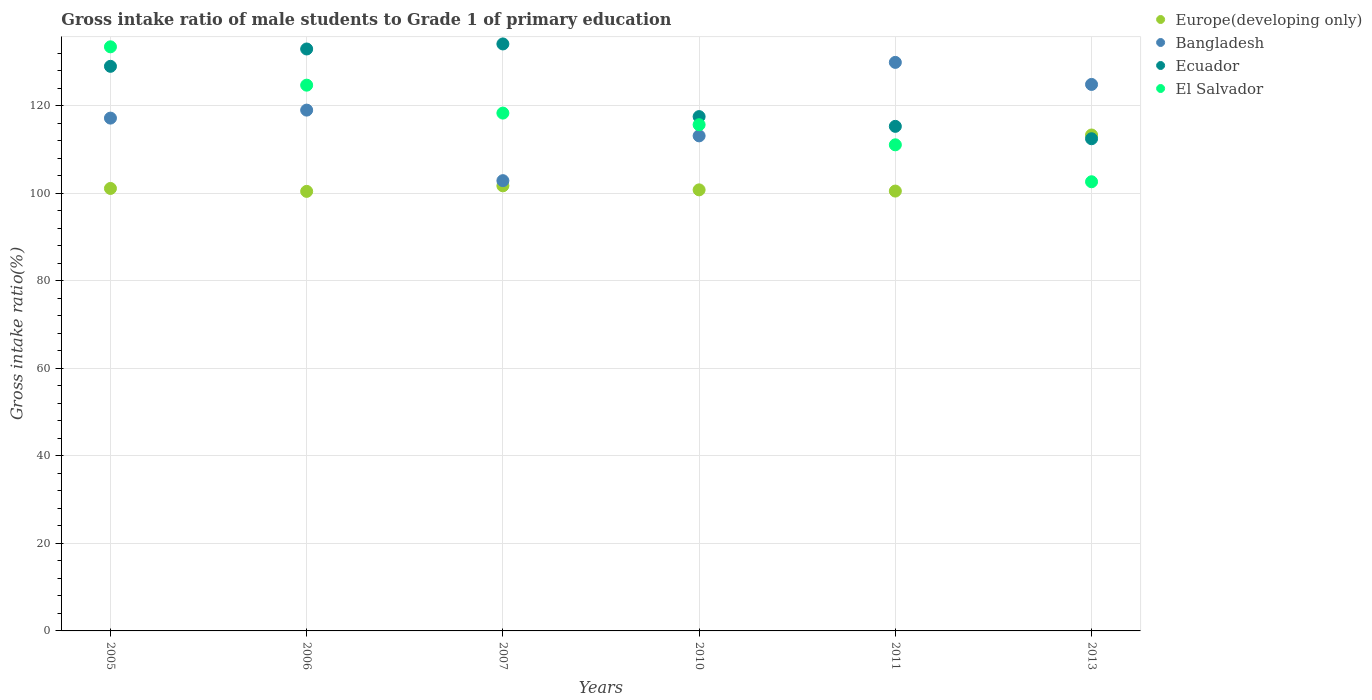What is the gross intake ratio in Europe(developing only) in 2007?
Provide a short and direct response. 101.71. Across all years, what is the maximum gross intake ratio in Ecuador?
Provide a short and direct response. 134.14. Across all years, what is the minimum gross intake ratio in Ecuador?
Offer a terse response. 112.47. What is the total gross intake ratio in Europe(developing only) in the graph?
Make the answer very short. 617.91. What is the difference between the gross intake ratio in Europe(developing only) in 2006 and that in 2010?
Make the answer very short. -0.35. What is the difference between the gross intake ratio in Bangladesh in 2013 and the gross intake ratio in Europe(developing only) in 2007?
Make the answer very short. 23.17. What is the average gross intake ratio in Bangladesh per year?
Provide a short and direct response. 117.84. In the year 2007, what is the difference between the gross intake ratio in Europe(developing only) and gross intake ratio in El Salvador?
Provide a short and direct response. -16.62. What is the ratio of the gross intake ratio in Europe(developing only) in 2005 to that in 2006?
Give a very brief answer. 1.01. Is the gross intake ratio in El Salvador in 2006 less than that in 2007?
Provide a succinct answer. No. Is the difference between the gross intake ratio in Europe(developing only) in 2010 and 2013 greater than the difference between the gross intake ratio in El Salvador in 2010 and 2013?
Keep it short and to the point. No. What is the difference between the highest and the second highest gross intake ratio in Bangladesh?
Your response must be concise. 5.04. What is the difference between the highest and the lowest gross intake ratio in Bangladesh?
Offer a terse response. 27.03. In how many years, is the gross intake ratio in Bangladesh greater than the average gross intake ratio in Bangladesh taken over all years?
Give a very brief answer. 3. Is it the case that in every year, the sum of the gross intake ratio in Bangladesh and gross intake ratio in Europe(developing only)  is greater than the gross intake ratio in El Salvador?
Offer a terse response. Yes. Does the gross intake ratio in Bangladesh monotonically increase over the years?
Offer a terse response. No. How many years are there in the graph?
Your answer should be very brief. 6. What is the difference between two consecutive major ticks on the Y-axis?
Offer a terse response. 20. How many legend labels are there?
Give a very brief answer. 4. How are the legend labels stacked?
Your answer should be compact. Vertical. What is the title of the graph?
Provide a short and direct response. Gross intake ratio of male students to Grade 1 of primary education. What is the label or title of the X-axis?
Make the answer very short. Years. What is the label or title of the Y-axis?
Your response must be concise. Gross intake ratio(%). What is the Gross intake ratio(%) of Europe(developing only) in 2005?
Give a very brief answer. 101.11. What is the Gross intake ratio(%) in Bangladesh in 2005?
Provide a short and direct response. 117.19. What is the Gross intake ratio(%) in Ecuador in 2005?
Your answer should be compact. 129.02. What is the Gross intake ratio(%) of El Salvador in 2005?
Your answer should be compact. 133.48. What is the Gross intake ratio(%) in Europe(developing only) in 2006?
Keep it short and to the point. 100.44. What is the Gross intake ratio(%) of Bangladesh in 2006?
Ensure brevity in your answer.  119.02. What is the Gross intake ratio(%) of Ecuador in 2006?
Provide a short and direct response. 132.98. What is the Gross intake ratio(%) in El Salvador in 2006?
Ensure brevity in your answer.  124.72. What is the Gross intake ratio(%) in Europe(developing only) in 2007?
Your answer should be compact. 101.71. What is the Gross intake ratio(%) in Bangladesh in 2007?
Ensure brevity in your answer.  102.89. What is the Gross intake ratio(%) in Ecuador in 2007?
Offer a very short reply. 134.14. What is the Gross intake ratio(%) of El Salvador in 2007?
Offer a very short reply. 118.33. What is the Gross intake ratio(%) of Europe(developing only) in 2010?
Provide a succinct answer. 100.79. What is the Gross intake ratio(%) of Bangladesh in 2010?
Offer a terse response. 113.13. What is the Gross intake ratio(%) in Ecuador in 2010?
Make the answer very short. 117.53. What is the Gross intake ratio(%) in El Salvador in 2010?
Provide a succinct answer. 115.68. What is the Gross intake ratio(%) in Europe(developing only) in 2011?
Provide a succinct answer. 100.51. What is the Gross intake ratio(%) of Bangladesh in 2011?
Ensure brevity in your answer.  129.92. What is the Gross intake ratio(%) of Ecuador in 2011?
Give a very brief answer. 115.3. What is the Gross intake ratio(%) of El Salvador in 2011?
Give a very brief answer. 111.08. What is the Gross intake ratio(%) in Europe(developing only) in 2013?
Your response must be concise. 113.33. What is the Gross intake ratio(%) of Bangladesh in 2013?
Offer a very short reply. 124.88. What is the Gross intake ratio(%) of Ecuador in 2013?
Offer a terse response. 112.47. What is the Gross intake ratio(%) in El Salvador in 2013?
Provide a succinct answer. 102.64. Across all years, what is the maximum Gross intake ratio(%) in Europe(developing only)?
Keep it short and to the point. 113.33. Across all years, what is the maximum Gross intake ratio(%) in Bangladesh?
Provide a succinct answer. 129.92. Across all years, what is the maximum Gross intake ratio(%) of Ecuador?
Make the answer very short. 134.14. Across all years, what is the maximum Gross intake ratio(%) in El Salvador?
Make the answer very short. 133.48. Across all years, what is the minimum Gross intake ratio(%) in Europe(developing only)?
Your answer should be very brief. 100.44. Across all years, what is the minimum Gross intake ratio(%) of Bangladesh?
Ensure brevity in your answer.  102.89. Across all years, what is the minimum Gross intake ratio(%) of Ecuador?
Provide a succinct answer. 112.47. Across all years, what is the minimum Gross intake ratio(%) in El Salvador?
Offer a very short reply. 102.64. What is the total Gross intake ratio(%) in Europe(developing only) in the graph?
Offer a terse response. 617.91. What is the total Gross intake ratio(%) of Bangladesh in the graph?
Give a very brief answer. 707.03. What is the total Gross intake ratio(%) in Ecuador in the graph?
Offer a very short reply. 741.45. What is the total Gross intake ratio(%) in El Salvador in the graph?
Offer a terse response. 705.93. What is the difference between the Gross intake ratio(%) of Europe(developing only) in 2005 and that in 2006?
Offer a terse response. 0.67. What is the difference between the Gross intake ratio(%) in Bangladesh in 2005 and that in 2006?
Make the answer very short. -1.83. What is the difference between the Gross intake ratio(%) of Ecuador in 2005 and that in 2006?
Provide a succinct answer. -3.96. What is the difference between the Gross intake ratio(%) of El Salvador in 2005 and that in 2006?
Your answer should be very brief. 8.76. What is the difference between the Gross intake ratio(%) in Europe(developing only) in 2005 and that in 2007?
Offer a terse response. -0.6. What is the difference between the Gross intake ratio(%) in Bangladesh in 2005 and that in 2007?
Offer a terse response. 14.29. What is the difference between the Gross intake ratio(%) of Ecuador in 2005 and that in 2007?
Keep it short and to the point. -5.11. What is the difference between the Gross intake ratio(%) in El Salvador in 2005 and that in 2007?
Keep it short and to the point. 15.15. What is the difference between the Gross intake ratio(%) in Europe(developing only) in 2005 and that in 2010?
Your answer should be compact. 0.32. What is the difference between the Gross intake ratio(%) in Bangladesh in 2005 and that in 2010?
Offer a very short reply. 4.06. What is the difference between the Gross intake ratio(%) in Ecuador in 2005 and that in 2010?
Provide a short and direct response. 11.49. What is the difference between the Gross intake ratio(%) of El Salvador in 2005 and that in 2010?
Provide a short and direct response. 17.8. What is the difference between the Gross intake ratio(%) in Europe(developing only) in 2005 and that in 2011?
Provide a succinct answer. 0.6. What is the difference between the Gross intake ratio(%) in Bangladesh in 2005 and that in 2011?
Provide a succinct answer. -12.73. What is the difference between the Gross intake ratio(%) in Ecuador in 2005 and that in 2011?
Offer a terse response. 13.72. What is the difference between the Gross intake ratio(%) in El Salvador in 2005 and that in 2011?
Ensure brevity in your answer.  22.39. What is the difference between the Gross intake ratio(%) of Europe(developing only) in 2005 and that in 2013?
Keep it short and to the point. -12.21. What is the difference between the Gross intake ratio(%) of Bangladesh in 2005 and that in 2013?
Give a very brief answer. -7.7. What is the difference between the Gross intake ratio(%) of Ecuador in 2005 and that in 2013?
Offer a terse response. 16.55. What is the difference between the Gross intake ratio(%) of El Salvador in 2005 and that in 2013?
Your response must be concise. 30.84. What is the difference between the Gross intake ratio(%) of Europe(developing only) in 2006 and that in 2007?
Ensure brevity in your answer.  -1.27. What is the difference between the Gross intake ratio(%) in Bangladesh in 2006 and that in 2007?
Provide a short and direct response. 16.12. What is the difference between the Gross intake ratio(%) in Ecuador in 2006 and that in 2007?
Offer a very short reply. -1.15. What is the difference between the Gross intake ratio(%) in El Salvador in 2006 and that in 2007?
Your response must be concise. 6.38. What is the difference between the Gross intake ratio(%) of Europe(developing only) in 2006 and that in 2010?
Make the answer very short. -0.35. What is the difference between the Gross intake ratio(%) in Bangladesh in 2006 and that in 2010?
Your response must be concise. 5.89. What is the difference between the Gross intake ratio(%) of Ecuador in 2006 and that in 2010?
Give a very brief answer. 15.45. What is the difference between the Gross intake ratio(%) of El Salvador in 2006 and that in 2010?
Make the answer very short. 9.03. What is the difference between the Gross intake ratio(%) in Europe(developing only) in 2006 and that in 2011?
Your answer should be very brief. -0.07. What is the difference between the Gross intake ratio(%) of Bangladesh in 2006 and that in 2011?
Offer a very short reply. -10.91. What is the difference between the Gross intake ratio(%) in Ecuador in 2006 and that in 2011?
Provide a succinct answer. 17.68. What is the difference between the Gross intake ratio(%) of El Salvador in 2006 and that in 2011?
Your answer should be very brief. 13.63. What is the difference between the Gross intake ratio(%) of Europe(developing only) in 2006 and that in 2013?
Make the answer very short. -12.88. What is the difference between the Gross intake ratio(%) in Bangladesh in 2006 and that in 2013?
Provide a succinct answer. -5.87. What is the difference between the Gross intake ratio(%) in Ecuador in 2006 and that in 2013?
Give a very brief answer. 20.51. What is the difference between the Gross intake ratio(%) of El Salvador in 2006 and that in 2013?
Ensure brevity in your answer.  22.07. What is the difference between the Gross intake ratio(%) in Europe(developing only) in 2007 and that in 2010?
Provide a succinct answer. 0.92. What is the difference between the Gross intake ratio(%) in Bangladesh in 2007 and that in 2010?
Make the answer very short. -10.24. What is the difference between the Gross intake ratio(%) of Ecuador in 2007 and that in 2010?
Offer a terse response. 16.6. What is the difference between the Gross intake ratio(%) in El Salvador in 2007 and that in 2010?
Offer a very short reply. 2.65. What is the difference between the Gross intake ratio(%) of Europe(developing only) in 2007 and that in 2011?
Give a very brief answer. 1.2. What is the difference between the Gross intake ratio(%) of Bangladesh in 2007 and that in 2011?
Keep it short and to the point. -27.03. What is the difference between the Gross intake ratio(%) in Ecuador in 2007 and that in 2011?
Offer a very short reply. 18.83. What is the difference between the Gross intake ratio(%) in El Salvador in 2007 and that in 2011?
Provide a short and direct response. 7.25. What is the difference between the Gross intake ratio(%) of Europe(developing only) in 2007 and that in 2013?
Ensure brevity in your answer.  -11.61. What is the difference between the Gross intake ratio(%) in Bangladesh in 2007 and that in 2013?
Ensure brevity in your answer.  -21.99. What is the difference between the Gross intake ratio(%) in Ecuador in 2007 and that in 2013?
Keep it short and to the point. 21.66. What is the difference between the Gross intake ratio(%) of El Salvador in 2007 and that in 2013?
Your answer should be very brief. 15.69. What is the difference between the Gross intake ratio(%) of Europe(developing only) in 2010 and that in 2011?
Your answer should be compact. 0.28. What is the difference between the Gross intake ratio(%) in Bangladesh in 2010 and that in 2011?
Give a very brief answer. -16.79. What is the difference between the Gross intake ratio(%) of Ecuador in 2010 and that in 2011?
Give a very brief answer. 2.23. What is the difference between the Gross intake ratio(%) in El Salvador in 2010 and that in 2011?
Make the answer very short. 4.6. What is the difference between the Gross intake ratio(%) of Europe(developing only) in 2010 and that in 2013?
Give a very brief answer. -12.54. What is the difference between the Gross intake ratio(%) of Bangladesh in 2010 and that in 2013?
Provide a succinct answer. -11.76. What is the difference between the Gross intake ratio(%) in Ecuador in 2010 and that in 2013?
Your answer should be very brief. 5.06. What is the difference between the Gross intake ratio(%) in El Salvador in 2010 and that in 2013?
Offer a terse response. 13.04. What is the difference between the Gross intake ratio(%) in Europe(developing only) in 2011 and that in 2013?
Your response must be concise. -12.81. What is the difference between the Gross intake ratio(%) in Bangladesh in 2011 and that in 2013?
Your answer should be compact. 5.04. What is the difference between the Gross intake ratio(%) of Ecuador in 2011 and that in 2013?
Keep it short and to the point. 2.83. What is the difference between the Gross intake ratio(%) of El Salvador in 2011 and that in 2013?
Provide a succinct answer. 8.44. What is the difference between the Gross intake ratio(%) of Europe(developing only) in 2005 and the Gross intake ratio(%) of Bangladesh in 2006?
Give a very brief answer. -17.9. What is the difference between the Gross intake ratio(%) of Europe(developing only) in 2005 and the Gross intake ratio(%) of Ecuador in 2006?
Keep it short and to the point. -31.87. What is the difference between the Gross intake ratio(%) in Europe(developing only) in 2005 and the Gross intake ratio(%) in El Salvador in 2006?
Give a very brief answer. -23.6. What is the difference between the Gross intake ratio(%) in Bangladesh in 2005 and the Gross intake ratio(%) in Ecuador in 2006?
Your response must be concise. -15.8. What is the difference between the Gross intake ratio(%) of Bangladesh in 2005 and the Gross intake ratio(%) of El Salvador in 2006?
Offer a terse response. -7.53. What is the difference between the Gross intake ratio(%) in Ecuador in 2005 and the Gross intake ratio(%) in El Salvador in 2006?
Your answer should be very brief. 4.31. What is the difference between the Gross intake ratio(%) of Europe(developing only) in 2005 and the Gross intake ratio(%) of Bangladesh in 2007?
Your answer should be very brief. -1.78. What is the difference between the Gross intake ratio(%) in Europe(developing only) in 2005 and the Gross intake ratio(%) in Ecuador in 2007?
Your response must be concise. -33.02. What is the difference between the Gross intake ratio(%) of Europe(developing only) in 2005 and the Gross intake ratio(%) of El Salvador in 2007?
Your answer should be compact. -17.22. What is the difference between the Gross intake ratio(%) of Bangladesh in 2005 and the Gross intake ratio(%) of Ecuador in 2007?
Offer a terse response. -16.95. What is the difference between the Gross intake ratio(%) in Bangladesh in 2005 and the Gross intake ratio(%) in El Salvador in 2007?
Provide a short and direct response. -1.15. What is the difference between the Gross intake ratio(%) of Ecuador in 2005 and the Gross intake ratio(%) of El Salvador in 2007?
Your answer should be very brief. 10.69. What is the difference between the Gross intake ratio(%) in Europe(developing only) in 2005 and the Gross intake ratio(%) in Bangladesh in 2010?
Your answer should be very brief. -12.02. What is the difference between the Gross intake ratio(%) in Europe(developing only) in 2005 and the Gross intake ratio(%) in Ecuador in 2010?
Provide a short and direct response. -16.42. What is the difference between the Gross intake ratio(%) in Europe(developing only) in 2005 and the Gross intake ratio(%) in El Salvador in 2010?
Provide a succinct answer. -14.57. What is the difference between the Gross intake ratio(%) of Bangladesh in 2005 and the Gross intake ratio(%) of Ecuador in 2010?
Your response must be concise. -0.34. What is the difference between the Gross intake ratio(%) of Bangladesh in 2005 and the Gross intake ratio(%) of El Salvador in 2010?
Offer a very short reply. 1.51. What is the difference between the Gross intake ratio(%) in Ecuador in 2005 and the Gross intake ratio(%) in El Salvador in 2010?
Provide a short and direct response. 13.34. What is the difference between the Gross intake ratio(%) in Europe(developing only) in 2005 and the Gross intake ratio(%) in Bangladesh in 2011?
Your answer should be very brief. -28.81. What is the difference between the Gross intake ratio(%) in Europe(developing only) in 2005 and the Gross intake ratio(%) in Ecuador in 2011?
Offer a terse response. -14.19. What is the difference between the Gross intake ratio(%) of Europe(developing only) in 2005 and the Gross intake ratio(%) of El Salvador in 2011?
Provide a short and direct response. -9.97. What is the difference between the Gross intake ratio(%) of Bangladesh in 2005 and the Gross intake ratio(%) of Ecuador in 2011?
Offer a very short reply. 1.88. What is the difference between the Gross intake ratio(%) of Bangladesh in 2005 and the Gross intake ratio(%) of El Salvador in 2011?
Make the answer very short. 6.1. What is the difference between the Gross intake ratio(%) of Ecuador in 2005 and the Gross intake ratio(%) of El Salvador in 2011?
Offer a terse response. 17.94. What is the difference between the Gross intake ratio(%) in Europe(developing only) in 2005 and the Gross intake ratio(%) in Bangladesh in 2013?
Provide a succinct answer. -23.77. What is the difference between the Gross intake ratio(%) in Europe(developing only) in 2005 and the Gross intake ratio(%) in Ecuador in 2013?
Make the answer very short. -11.36. What is the difference between the Gross intake ratio(%) in Europe(developing only) in 2005 and the Gross intake ratio(%) in El Salvador in 2013?
Provide a short and direct response. -1.53. What is the difference between the Gross intake ratio(%) in Bangladesh in 2005 and the Gross intake ratio(%) in Ecuador in 2013?
Give a very brief answer. 4.71. What is the difference between the Gross intake ratio(%) in Bangladesh in 2005 and the Gross intake ratio(%) in El Salvador in 2013?
Ensure brevity in your answer.  14.54. What is the difference between the Gross intake ratio(%) of Ecuador in 2005 and the Gross intake ratio(%) of El Salvador in 2013?
Ensure brevity in your answer.  26.38. What is the difference between the Gross intake ratio(%) in Europe(developing only) in 2006 and the Gross intake ratio(%) in Bangladesh in 2007?
Provide a succinct answer. -2.45. What is the difference between the Gross intake ratio(%) of Europe(developing only) in 2006 and the Gross intake ratio(%) of Ecuador in 2007?
Offer a terse response. -33.69. What is the difference between the Gross intake ratio(%) of Europe(developing only) in 2006 and the Gross intake ratio(%) of El Salvador in 2007?
Keep it short and to the point. -17.89. What is the difference between the Gross intake ratio(%) in Bangladesh in 2006 and the Gross intake ratio(%) in Ecuador in 2007?
Give a very brief answer. -15.12. What is the difference between the Gross intake ratio(%) in Bangladesh in 2006 and the Gross intake ratio(%) in El Salvador in 2007?
Your answer should be compact. 0.68. What is the difference between the Gross intake ratio(%) in Ecuador in 2006 and the Gross intake ratio(%) in El Salvador in 2007?
Give a very brief answer. 14.65. What is the difference between the Gross intake ratio(%) in Europe(developing only) in 2006 and the Gross intake ratio(%) in Bangladesh in 2010?
Offer a very short reply. -12.68. What is the difference between the Gross intake ratio(%) in Europe(developing only) in 2006 and the Gross intake ratio(%) in Ecuador in 2010?
Give a very brief answer. -17.09. What is the difference between the Gross intake ratio(%) in Europe(developing only) in 2006 and the Gross intake ratio(%) in El Salvador in 2010?
Your response must be concise. -15.24. What is the difference between the Gross intake ratio(%) of Bangladesh in 2006 and the Gross intake ratio(%) of Ecuador in 2010?
Give a very brief answer. 1.48. What is the difference between the Gross intake ratio(%) of Bangladesh in 2006 and the Gross intake ratio(%) of El Salvador in 2010?
Your answer should be very brief. 3.33. What is the difference between the Gross intake ratio(%) in Ecuador in 2006 and the Gross intake ratio(%) in El Salvador in 2010?
Make the answer very short. 17.3. What is the difference between the Gross intake ratio(%) in Europe(developing only) in 2006 and the Gross intake ratio(%) in Bangladesh in 2011?
Your answer should be very brief. -29.48. What is the difference between the Gross intake ratio(%) in Europe(developing only) in 2006 and the Gross intake ratio(%) in Ecuador in 2011?
Your answer should be very brief. -14.86. What is the difference between the Gross intake ratio(%) of Europe(developing only) in 2006 and the Gross intake ratio(%) of El Salvador in 2011?
Offer a terse response. -10.64. What is the difference between the Gross intake ratio(%) of Bangladesh in 2006 and the Gross intake ratio(%) of Ecuador in 2011?
Offer a terse response. 3.71. What is the difference between the Gross intake ratio(%) in Bangladesh in 2006 and the Gross intake ratio(%) in El Salvador in 2011?
Offer a very short reply. 7.93. What is the difference between the Gross intake ratio(%) of Ecuador in 2006 and the Gross intake ratio(%) of El Salvador in 2011?
Provide a succinct answer. 21.9. What is the difference between the Gross intake ratio(%) of Europe(developing only) in 2006 and the Gross intake ratio(%) of Bangladesh in 2013?
Your response must be concise. -24.44. What is the difference between the Gross intake ratio(%) in Europe(developing only) in 2006 and the Gross intake ratio(%) in Ecuador in 2013?
Offer a terse response. -12.03. What is the difference between the Gross intake ratio(%) in Europe(developing only) in 2006 and the Gross intake ratio(%) in El Salvador in 2013?
Give a very brief answer. -2.2. What is the difference between the Gross intake ratio(%) in Bangladesh in 2006 and the Gross intake ratio(%) in Ecuador in 2013?
Your response must be concise. 6.54. What is the difference between the Gross intake ratio(%) in Bangladesh in 2006 and the Gross intake ratio(%) in El Salvador in 2013?
Make the answer very short. 16.37. What is the difference between the Gross intake ratio(%) of Ecuador in 2006 and the Gross intake ratio(%) of El Salvador in 2013?
Make the answer very short. 30.34. What is the difference between the Gross intake ratio(%) in Europe(developing only) in 2007 and the Gross intake ratio(%) in Bangladesh in 2010?
Make the answer very short. -11.42. What is the difference between the Gross intake ratio(%) of Europe(developing only) in 2007 and the Gross intake ratio(%) of Ecuador in 2010?
Ensure brevity in your answer.  -15.82. What is the difference between the Gross intake ratio(%) in Europe(developing only) in 2007 and the Gross intake ratio(%) in El Salvador in 2010?
Keep it short and to the point. -13.97. What is the difference between the Gross intake ratio(%) of Bangladesh in 2007 and the Gross intake ratio(%) of Ecuador in 2010?
Ensure brevity in your answer.  -14.64. What is the difference between the Gross intake ratio(%) in Bangladesh in 2007 and the Gross intake ratio(%) in El Salvador in 2010?
Provide a succinct answer. -12.79. What is the difference between the Gross intake ratio(%) of Ecuador in 2007 and the Gross intake ratio(%) of El Salvador in 2010?
Provide a succinct answer. 18.45. What is the difference between the Gross intake ratio(%) in Europe(developing only) in 2007 and the Gross intake ratio(%) in Bangladesh in 2011?
Your answer should be very brief. -28.21. What is the difference between the Gross intake ratio(%) in Europe(developing only) in 2007 and the Gross intake ratio(%) in Ecuador in 2011?
Provide a short and direct response. -13.59. What is the difference between the Gross intake ratio(%) of Europe(developing only) in 2007 and the Gross intake ratio(%) of El Salvador in 2011?
Keep it short and to the point. -9.37. What is the difference between the Gross intake ratio(%) of Bangladesh in 2007 and the Gross intake ratio(%) of Ecuador in 2011?
Provide a succinct answer. -12.41. What is the difference between the Gross intake ratio(%) in Bangladesh in 2007 and the Gross intake ratio(%) in El Salvador in 2011?
Your response must be concise. -8.19. What is the difference between the Gross intake ratio(%) of Ecuador in 2007 and the Gross intake ratio(%) of El Salvador in 2011?
Make the answer very short. 23.05. What is the difference between the Gross intake ratio(%) in Europe(developing only) in 2007 and the Gross intake ratio(%) in Bangladesh in 2013?
Offer a terse response. -23.17. What is the difference between the Gross intake ratio(%) in Europe(developing only) in 2007 and the Gross intake ratio(%) in Ecuador in 2013?
Give a very brief answer. -10.76. What is the difference between the Gross intake ratio(%) of Europe(developing only) in 2007 and the Gross intake ratio(%) of El Salvador in 2013?
Provide a succinct answer. -0.93. What is the difference between the Gross intake ratio(%) in Bangladesh in 2007 and the Gross intake ratio(%) in Ecuador in 2013?
Give a very brief answer. -9.58. What is the difference between the Gross intake ratio(%) in Bangladesh in 2007 and the Gross intake ratio(%) in El Salvador in 2013?
Offer a terse response. 0.25. What is the difference between the Gross intake ratio(%) of Ecuador in 2007 and the Gross intake ratio(%) of El Salvador in 2013?
Provide a succinct answer. 31.49. What is the difference between the Gross intake ratio(%) in Europe(developing only) in 2010 and the Gross intake ratio(%) in Bangladesh in 2011?
Give a very brief answer. -29.13. What is the difference between the Gross intake ratio(%) of Europe(developing only) in 2010 and the Gross intake ratio(%) of Ecuador in 2011?
Your answer should be compact. -14.51. What is the difference between the Gross intake ratio(%) in Europe(developing only) in 2010 and the Gross intake ratio(%) in El Salvador in 2011?
Give a very brief answer. -10.29. What is the difference between the Gross intake ratio(%) of Bangladesh in 2010 and the Gross intake ratio(%) of Ecuador in 2011?
Ensure brevity in your answer.  -2.17. What is the difference between the Gross intake ratio(%) in Bangladesh in 2010 and the Gross intake ratio(%) in El Salvador in 2011?
Your answer should be compact. 2.05. What is the difference between the Gross intake ratio(%) of Ecuador in 2010 and the Gross intake ratio(%) of El Salvador in 2011?
Make the answer very short. 6.45. What is the difference between the Gross intake ratio(%) in Europe(developing only) in 2010 and the Gross intake ratio(%) in Bangladesh in 2013?
Provide a short and direct response. -24.09. What is the difference between the Gross intake ratio(%) of Europe(developing only) in 2010 and the Gross intake ratio(%) of Ecuador in 2013?
Keep it short and to the point. -11.68. What is the difference between the Gross intake ratio(%) in Europe(developing only) in 2010 and the Gross intake ratio(%) in El Salvador in 2013?
Your answer should be very brief. -1.85. What is the difference between the Gross intake ratio(%) of Bangladesh in 2010 and the Gross intake ratio(%) of Ecuador in 2013?
Your answer should be very brief. 0.66. What is the difference between the Gross intake ratio(%) of Bangladesh in 2010 and the Gross intake ratio(%) of El Salvador in 2013?
Offer a terse response. 10.49. What is the difference between the Gross intake ratio(%) of Ecuador in 2010 and the Gross intake ratio(%) of El Salvador in 2013?
Offer a very short reply. 14.89. What is the difference between the Gross intake ratio(%) in Europe(developing only) in 2011 and the Gross intake ratio(%) in Bangladesh in 2013?
Offer a terse response. -24.37. What is the difference between the Gross intake ratio(%) in Europe(developing only) in 2011 and the Gross intake ratio(%) in Ecuador in 2013?
Keep it short and to the point. -11.96. What is the difference between the Gross intake ratio(%) in Europe(developing only) in 2011 and the Gross intake ratio(%) in El Salvador in 2013?
Your answer should be compact. -2.13. What is the difference between the Gross intake ratio(%) in Bangladesh in 2011 and the Gross intake ratio(%) in Ecuador in 2013?
Your response must be concise. 17.45. What is the difference between the Gross intake ratio(%) of Bangladesh in 2011 and the Gross intake ratio(%) of El Salvador in 2013?
Offer a very short reply. 27.28. What is the difference between the Gross intake ratio(%) of Ecuador in 2011 and the Gross intake ratio(%) of El Salvador in 2013?
Your answer should be very brief. 12.66. What is the average Gross intake ratio(%) of Europe(developing only) per year?
Provide a short and direct response. 102.98. What is the average Gross intake ratio(%) in Bangladesh per year?
Provide a succinct answer. 117.84. What is the average Gross intake ratio(%) of Ecuador per year?
Provide a short and direct response. 123.57. What is the average Gross intake ratio(%) in El Salvador per year?
Give a very brief answer. 117.66. In the year 2005, what is the difference between the Gross intake ratio(%) of Europe(developing only) and Gross intake ratio(%) of Bangladesh?
Your answer should be very brief. -16.07. In the year 2005, what is the difference between the Gross intake ratio(%) of Europe(developing only) and Gross intake ratio(%) of Ecuador?
Offer a terse response. -27.91. In the year 2005, what is the difference between the Gross intake ratio(%) of Europe(developing only) and Gross intake ratio(%) of El Salvador?
Provide a succinct answer. -32.36. In the year 2005, what is the difference between the Gross intake ratio(%) in Bangladesh and Gross intake ratio(%) in Ecuador?
Your response must be concise. -11.83. In the year 2005, what is the difference between the Gross intake ratio(%) in Bangladesh and Gross intake ratio(%) in El Salvador?
Keep it short and to the point. -16.29. In the year 2005, what is the difference between the Gross intake ratio(%) in Ecuador and Gross intake ratio(%) in El Salvador?
Provide a short and direct response. -4.46. In the year 2006, what is the difference between the Gross intake ratio(%) in Europe(developing only) and Gross intake ratio(%) in Bangladesh?
Your response must be concise. -18.57. In the year 2006, what is the difference between the Gross intake ratio(%) in Europe(developing only) and Gross intake ratio(%) in Ecuador?
Your answer should be very brief. -32.54. In the year 2006, what is the difference between the Gross intake ratio(%) in Europe(developing only) and Gross intake ratio(%) in El Salvador?
Keep it short and to the point. -24.27. In the year 2006, what is the difference between the Gross intake ratio(%) of Bangladesh and Gross intake ratio(%) of Ecuador?
Offer a very short reply. -13.97. In the year 2006, what is the difference between the Gross intake ratio(%) in Bangladesh and Gross intake ratio(%) in El Salvador?
Give a very brief answer. -5.7. In the year 2006, what is the difference between the Gross intake ratio(%) in Ecuador and Gross intake ratio(%) in El Salvador?
Offer a very short reply. 8.27. In the year 2007, what is the difference between the Gross intake ratio(%) in Europe(developing only) and Gross intake ratio(%) in Bangladesh?
Your answer should be compact. -1.18. In the year 2007, what is the difference between the Gross intake ratio(%) of Europe(developing only) and Gross intake ratio(%) of Ecuador?
Give a very brief answer. -32.42. In the year 2007, what is the difference between the Gross intake ratio(%) of Europe(developing only) and Gross intake ratio(%) of El Salvador?
Provide a short and direct response. -16.62. In the year 2007, what is the difference between the Gross intake ratio(%) of Bangladesh and Gross intake ratio(%) of Ecuador?
Ensure brevity in your answer.  -31.24. In the year 2007, what is the difference between the Gross intake ratio(%) of Bangladesh and Gross intake ratio(%) of El Salvador?
Offer a very short reply. -15.44. In the year 2007, what is the difference between the Gross intake ratio(%) of Ecuador and Gross intake ratio(%) of El Salvador?
Your response must be concise. 15.8. In the year 2010, what is the difference between the Gross intake ratio(%) of Europe(developing only) and Gross intake ratio(%) of Bangladesh?
Ensure brevity in your answer.  -12.34. In the year 2010, what is the difference between the Gross intake ratio(%) of Europe(developing only) and Gross intake ratio(%) of Ecuador?
Keep it short and to the point. -16.74. In the year 2010, what is the difference between the Gross intake ratio(%) of Europe(developing only) and Gross intake ratio(%) of El Salvador?
Make the answer very short. -14.89. In the year 2010, what is the difference between the Gross intake ratio(%) of Bangladesh and Gross intake ratio(%) of Ecuador?
Give a very brief answer. -4.4. In the year 2010, what is the difference between the Gross intake ratio(%) of Bangladesh and Gross intake ratio(%) of El Salvador?
Your response must be concise. -2.55. In the year 2010, what is the difference between the Gross intake ratio(%) of Ecuador and Gross intake ratio(%) of El Salvador?
Ensure brevity in your answer.  1.85. In the year 2011, what is the difference between the Gross intake ratio(%) in Europe(developing only) and Gross intake ratio(%) in Bangladesh?
Provide a short and direct response. -29.41. In the year 2011, what is the difference between the Gross intake ratio(%) in Europe(developing only) and Gross intake ratio(%) in Ecuador?
Ensure brevity in your answer.  -14.79. In the year 2011, what is the difference between the Gross intake ratio(%) of Europe(developing only) and Gross intake ratio(%) of El Salvador?
Provide a succinct answer. -10.57. In the year 2011, what is the difference between the Gross intake ratio(%) in Bangladesh and Gross intake ratio(%) in Ecuador?
Offer a very short reply. 14.62. In the year 2011, what is the difference between the Gross intake ratio(%) in Bangladesh and Gross intake ratio(%) in El Salvador?
Offer a terse response. 18.84. In the year 2011, what is the difference between the Gross intake ratio(%) of Ecuador and Gross intake ratio(%) of El Salvador?
Offer a terse response. 4.22. In the year 2013, what is the difference between the Gross intake ratio(%) in Europe(developing only) and Gross intake ratio(%) in Bangladesh?
Your response must be concise. -11.56. In the year 2013, what is the difference between the Gross intake ratio(%) in Europe(developing only) and Gross intake ratio(%) in Ecuador?
Your answer should be very brief. 0.86. In the year 2013, what is the difference between the Gross intake ratio(%) in Europe(developing only) and Gross intake ratio(%) in El Salvador?
Ensure brevity in your answer.  10.69. In the year 2013, what is the difference between the Gross intake ratio(%) in Bangladesh and Gross intake ratio(%) in Ecuador?
Give a very brief answer. 12.41. In the year 2013, what is the difference between the Gross intake ratio(%) of Bangladesh and Gross intake ratio(%) of El Salvador?
Offer a terse response. 22.24. In the year 2013, what is the difference between the Gross intake ratio(%) of Ecuador and Gross intake ratio(%) of El Salvador?
Offer a terse response. 9.83. What is the ratio of the Gross intake ratio(%) of Europe(developing only) in 2005 to that in 2006?
Your answer should be compact. 1.01. What is the ratio of the Gross intake ratio(%) in Bangladesh in 2005 to that in 2006?
Provide a succinct answer. 0.98. What is the ratio of the Gross intake ratio(%) of Ecuador in 2005 to that in 2006?
Provide a succinct answer. 0.97. What is the ratio of the Gross intake ratio(%) in El Salvador in 2005 to that in 2006?
Keep it short and to the point. 1.07. What is the ratio of the Gross intake ratio(%) of Europe(developing only) in 2005 to that in 2007?
Make the answer very short. 0.99. What is the ratio of the Gross intake ratio(%) of Bangladesh in 2005 to that in 2007?
Provide a succinct answer. 1.14. What is the ratio of the Gross intake ratio(%) of Ecuador in 2005 to that in 2007?
Make the answer very short. 0.96. What is the ratio of the Gross intake ratio(%) in El Salvador in 2005 to that in 2007?
Provide a succinct answer. 1.13. What is the ratio of the Gross intake ratio(%) in Europe(developing only) in 2005 to that in 2010?
Provide a succinct answer. 1. What is the ratio of the Gross intake ratio(%) in Bangladesh in 2005 to that in 2010?
Your answer should be very brief. 1.04. What is the ratio of the Gross intake ratio(%) of Ecuador in 2005 to that in 2010?
Ensure brevity in your answer.  1.1. What is the ratio of the Gross intake ratio(%) of El Salvador in 2005 to that in 2010?
Your response must be concise. 1.15. What is the ratio of the Gross intake ratio(%) of Europe(developing only) in 2005 to that in 2011?
Offer a very short reply. 1.01. What is the ratio of the Gross intake ratio(%) in Bangladesh in 2005 to that in 2011?
Your answer should be very brief. 0.9. What is the ratio of the Gross intake ratio(%) of Ecuador in 2005 to that in 2011?
Your answer should be compact. 1.12. What is the ratio of the Gross intake ratio(%) of El Salvador in 2005 to that in 2011?
Your response must be concise. 1.2. What is the ratio of the Gross intake ratio(%) in Europe(developing only) in 2005 to that in 2013?
Provide a succinct answer. 0.89. What is the ratio of the Gross intake ratio(%) in Bangladesh in 2005 to that in 2013?
Offer a very short reply. 0.94. What is the ratio of the Gross intake ratio(%) of Ecuador in 2005 to that in 2013?
Offer a very short reply. 1.15. What is the ratio of the Gross intake ratio(%) in El Salvador in 2005 to that in 2013?
Keep it short and to the point. 1.3. What is the ratio of the Gross intake ratio(%) of Europe(developing only) in 2006 to that in 2007?
Make the answer very short. 0.99. What is the ratio of the Gross intake ratio(%) of Bangladesh in 2006 to that in 2007?
Ensure brevity in your answer.  1.16. What is the ratio of the Gross intake ratio(%) in El Salvador in 2006 to that in 2007?
Offer a very short reply. 1.05. What is the ratio of the Gross intake ratio(%) of Europe(developing only) in 2006 to that in 2010?
Your answer should be compact. 1. What is the ratio of the Gross intake ratio(%) of Bangladesh in 2006 to that in 2010?
Make the answer very short. 1.05. What is the ratio of the Gross intake ratio(%) of Ecuador in 2006 to that in 2010?
Offer a terse response. 1.13. What is the ratio of the Gross intake ratio(%) of El Salvador in 2006 to that in 2010?
Make the answer very short. 1.08. What is the ratio of the Gross intake ratio(%) in Europe(developing only) in 2006 to that in 2011?
Your response must be concise. 1. What is the ratio of the Gross intake ratio(%) in Bangladesh in 2006 to that in 2011?
Provide a short and direct response. 0.92. What is the ratio of the Gross intake ratio(%) in Ecuador in 2006 to that in 2011?
Provide a short and direct response. 1.15. What is the ratio of the Gross intake ratio(%) of El Salvador in 2006 to that in 2011?
Your answer should be very brief. 1.12. What is the ratio of the Gross intake ratio(%) in Europe(developing only) in 2006 to that in 2013?
Offer a terse response. 0.89. What is the ratio of the Gross intake ratio(%) in Bangladesh in 2006 to that in 2013?
Provide a succinct answer. 0.95. What is the ratio of the Gross intake ratio(%) of Ecuador in 2006 to that in 2013?
Provide a succinct answer. 1.18. What is the ratio of the Gross intake ratio(%) of El Salvador in 2006 to that in 2013?
Your answer should be compact. 1.22. What is the ratio of the Gross intake ratio(%) in Europe(developing only) in 2007 to that in 2010?
Keep it short and to the point. 1.01. What is the ratio of the Gross intake ratio(%) in Bangladesh in 2007 to that in 2010?
Ensure brevity in your answer.  0.91. What is the ratio of the Gross intake ratio(%) of Ecuador in 2007 to that in 2010?
Provide a succinct answer. 1.14. What is the ratio of the Gross intake ratio(%) in El Salvador in 2007 to that in 2010?
Provide a short and direct response. 1.02. What is the ratio of the Gross intake ratio(%) of Europe(developing only) in 2007 to that in 2011?
Your response must be concise. 1.01. What is the ratio of the Gross intake ratio(%) in Bangladesh in 2007 to that in 2011?
Give a very brief answer. 0.79. What is the ratio of the Gross intake ratio(%) in Ecuador in 2007 to that in 2011?
Provide a succinct answer. 1.16. What is the ratio of the Gross intake ratio(%) in El Salvador in 2007 to that in 2011?
Your answer should be compact. 1.07. What is the ratio of the Gross intake ratio(%) in Europe(developing only) in 2007 to that in 2013?
Ensure brevity in your answer.  0.9. What is the ratio of the Gross intake ratio(%) of Bangladesh in 2007 to that in 2013?
Make the answer very short. 0.82. What is the ratio of the Gross intake ratio(%) in Ecuador in 2007 to that in 2013?
Give a very brief answer. 1.19. What is the ratio of the Gross intake ratio(%) in El Salvador in 2007 to that in 2013?
Your response must be concise. 1.15. What is the ratio of the Gross intake ratio(%) in Europe(developing only) in 2010 to that in 2011?
Keep it short and to the point. 1. What is the ratio of the Gross intake ratio(%) of Bangladesh in 2010 to that in 2011?
Offer a very short reply. 0.87. What is the ratio of the Gross intake ratio(%) of Ecuador in 2010 to that in 2011?
Make the answer very short. 1.02. What is the ratio of the Gross intake ratio(%) in El Salvador in 2010 to that in 2011?
Give a very brief answer. 1.04. What is the ratio of the Gross intake ratio(%) in Europe(developing only) in 2010 to that in 2013?
Offer a terse response. 0.89. What is the ratio of the Gross intake ratio(%) in Bangladesh in 2010 to that in 2013?
Your response must be concise. 0.91. What is the ratio of the Gross intake ratio(%) in Ecuador in 2010 to that in 2013?
Offer a very short reply. 1.04. What is the ratio of the Gross intake ratio(%) of El Salvador in 2010 to that in 2013?
Offer a very short reply. 1.13. What is the ratio of the Gross intake ratio(%) in Europe(developing only) in 2011 to that in 2013?
Your response must be concise. 0.89. What is the ratio of the Gross intake ratio(%) of Bangladesh in 2011 to that in 2013?
Your answer should be compact. 1.04. What is the ratio of the Gross intake ratio(%) in Ecuador in 2011 to that in 2013?
Make the answer very short. 1.03. What is the ratio of the Gross intake ratio(%) in El Salvador in 2011 to that in 2013?
Keep it short and to the point. 1.08. What is the difference between the highest and the second highest Gross intake ratio(%) of Europe(developing only)?
Make the answer very short. 11.61. What is the difference between the highest and the second highest Gross intake ratio(%) in Bangladesh?
Your answer should be compact. 5.04. What is the difference between the highest and the second highest Gross intake ratio(%) of Ecuador?
Keep it short and to the point. 1.15. What is the difference between the highest and the second highest Gross intake ratio(%) of El Salvador?
Offer a terse response. 8.76. What is the difference between the highest and the lowest Gross intake ratio(%) of Europe(developing only)?
Your response must be concise. 12.88. What is the difference between the highest and the lowest Gross intake ratio(%) in Bangladesh?
Keep it short and to the point. 27.03. What is the difference between the highest and the lowest Gross intake ratio(%) of Ecuador?
Give a very brief answer. 21.66. What is the difference between the highest and the lowest Gross intake ratio(%) of El Salvador?
Your answer should be very brief. 30.84. 